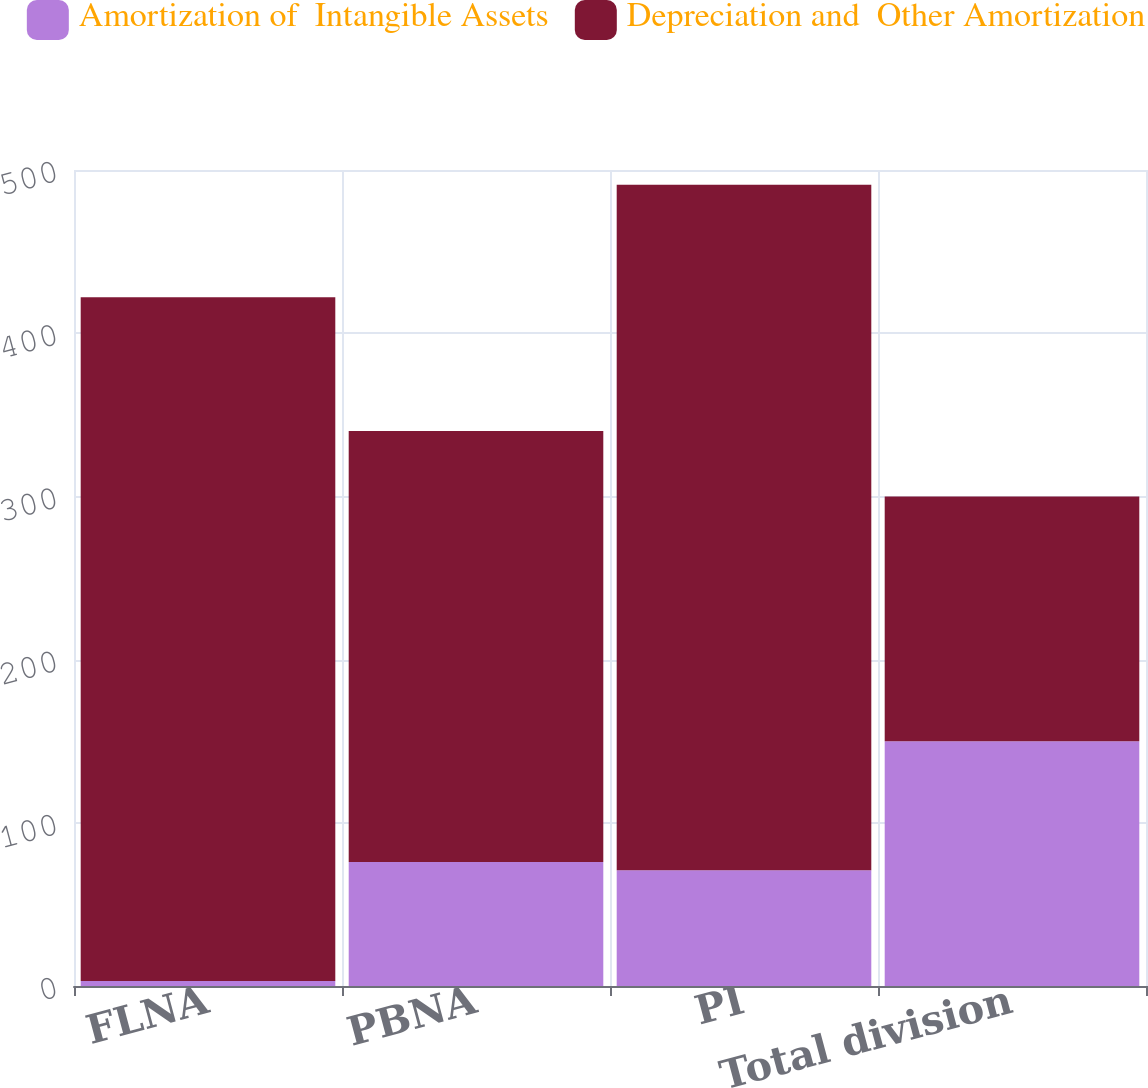<chart> <loc_0><loc_0><loc_500><loc_500><stacked_bar_chart><ecel><fcel>FLNA<fcel>PBNA<fcel>PI<fcel>Total division<nl><fcel>Amortization of  Intangible Assets<fcel>3<fcel>76<fcel>71<fcel>150<nl><fcel>Depreciation and  Other Amortization<fcel>419<fcel>264<fcel>420<fcel>150<nl></chart> 